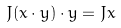Convert formula to latex. <formula><loc_0><loc_0><loc_500><loc_500>J ( x \cdot y ) \cdot y = J x</formula> 